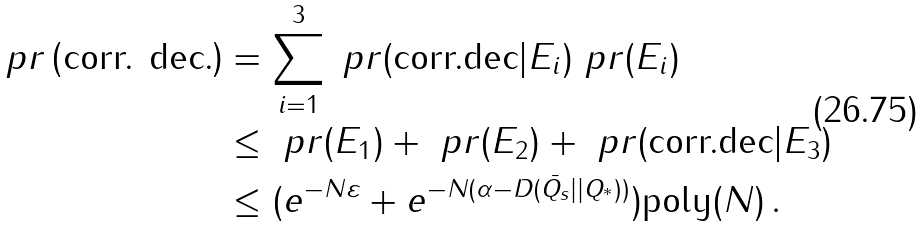Convert formula to latex. <formula><loc_0><loc_0><loc_500><loc_500>\ p r \left ( \text {corr. dec.} \right ) & = \sum _ { i = 1 } ^ { 3 } \ p r ( \text {corr.dec} | E _ { i } ) \ p r ( E _ { i } ) \\ & \leq \ p r ( E _ { 1 } ) + \ p r ( E _ { 2 } ) + \ p r ( \text {corr.dec} | E _ { 3 } ) \\ & \leq ( e ^ { - N \varepsilon } + { e ^ { - N ( \alpha - D ( \bar { Q _ { s } } | | Q _ { ^ { * } } ) ) } } ) \text {poly} ( N ) \, .</formula> 